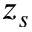<formula> <loc_0><loc_0><loc_500><loc_500>z _ { s }</formula> 